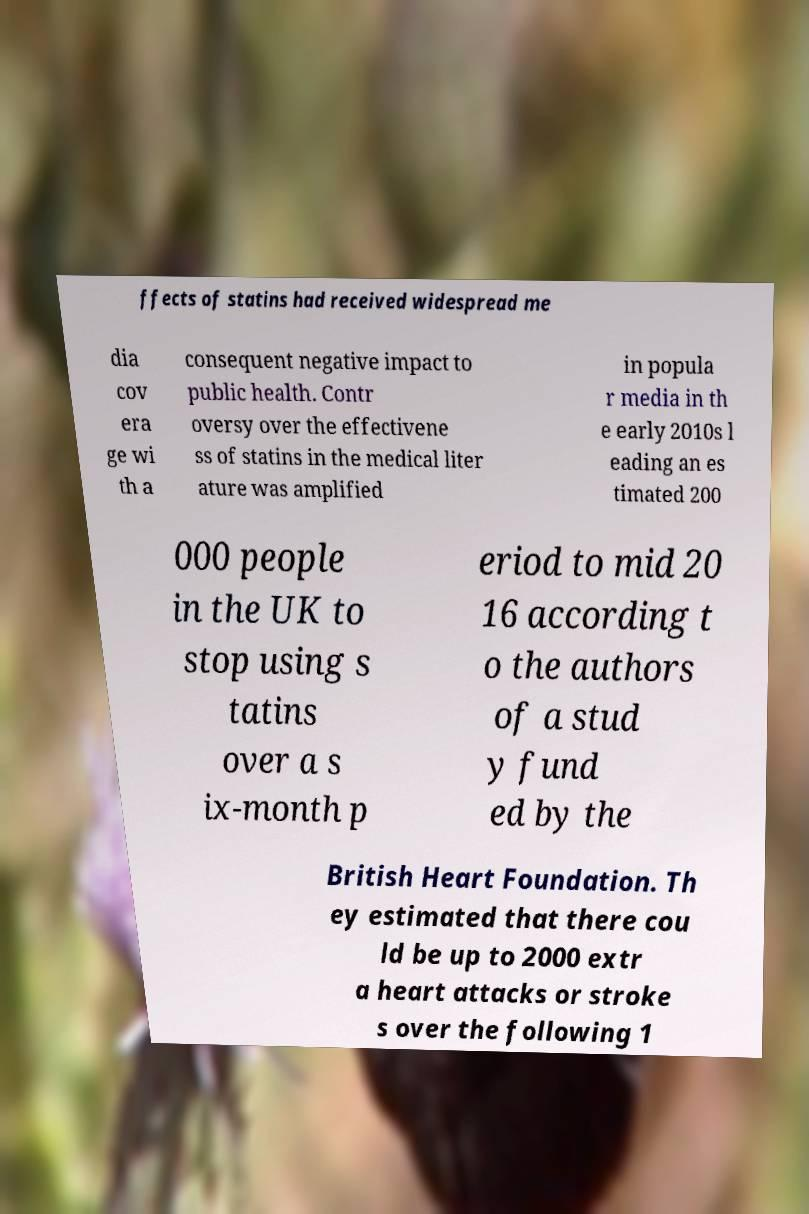I need the written content from this picture converted into text. Can you do that? ffects of statins had received widespread me dia cov era ge wi th a consequent negative impact to public health. Contr oversy over the effectivene ss of statins in the medical liter ature was amplified in popula r media in th e early 2010s l eading an es timated 200 000 people in the UK to stop using s tatins over a s ix-month p eriod to mid 20 16 according t o the authors of a stud y fund ed by the British Heart Foundation. Th ey estimated that there cou ld be up to 2000 extr a heart attacks or stroke s over the following 1 